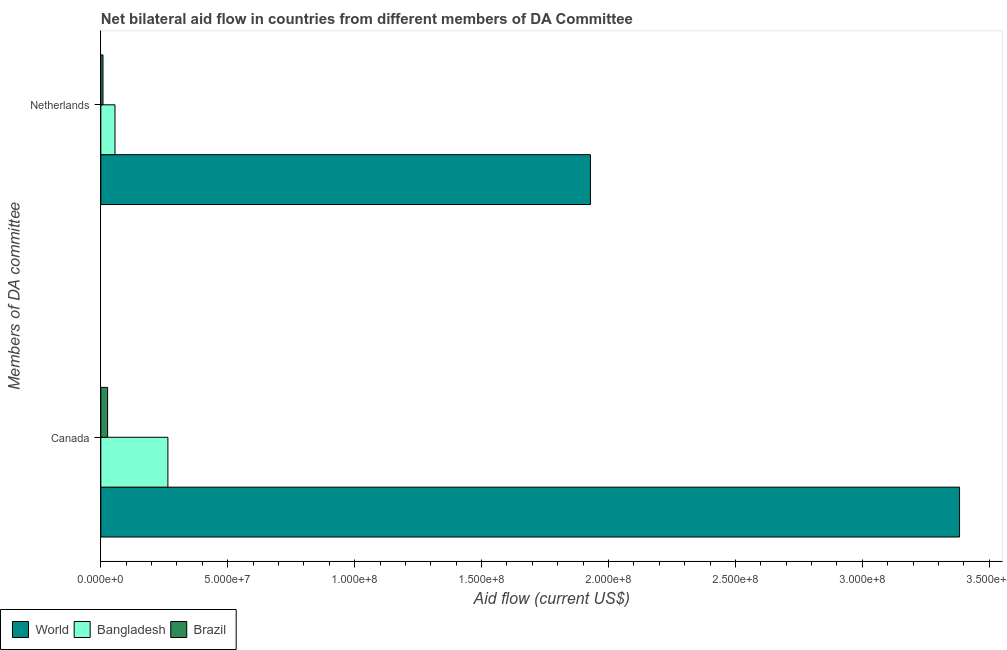How many different coloured bars are there?
Keep it short and to the point. 3. Are the number of bars on each tick of the Y-axis equal?
Your answer should be very brief. Yes. How many bars are there on the 1st tick from the top?
Provide a short and direct response. 3. How many bars are there on the 1st tick from the bottom?
Your answer should be compact. 3. What is the amount of aid given by canada in World?
Your answer should be compact. 3.38e+08. Across all countries, what is the maximum amount of aid given by canada?
Give a very brief answer. 3.38e+08. Across all countries, what is the minimum amount of aid given by netherlands?
Make the answer very short. 8.50e+05. What is the total amount of aid given by canada in the graph?
Your answer should be very brief. 3.67e+08. What is the difference between the amount of aid given by netherlands in World and that in Brazil?
Offer a terse response. 1.92e+08. What is the difference between the amount of aid given by canada in World and the amount of aid given by netherlands in Bangladesh?
Provide a short and direct response. 3.33e+08. What is the average amount of aid given by canada per country?
Ensure brevity in your answer.  1.22e+08. What is the difference between the amount of aid given by canada and amount of aid given by netherlands in Bangladesh?
Provide a short and direct response. 2.08e+07. What is the ratio of the amount of aid given by canada in World to that in Bangladesh?
Ensure brevity in your answer.  12.81. Is the amount of aid given by canada in World less than that in Brazil?
Your response must be concise. No. How many bars are there?
Make the answer very short. 6. Are the values on the major ticks of X-axis written in scientific E-notation?
Give a very brief answer. Yes. Does the graph contain any zero values?
Make the answer very short. No. Does the graph contain grids?
Give a very brief answer. No. Where does the legend appear in the graph?
Provide a succinct answer. Bottom left. How are the legend labels stacked?
Provide a short and direct response. Horizontal. What is the title of the graph?
Offer a very short reply. Net bilateral aid flow in countries from different members of DA Committee. Does "United Arab Emirates" appear as one of the legend labels in the graph?
Ensure brevity in your answer.  No. What is the label or title of the Y-axis?
Your answer should be compact. Members of DA committee. What is the Aid flow (current US$) of World in Canada?
Make the answer very short. 3.38e+08. What is the Aid flow (current US$) of Bangladesh in Canada?
Ensure brevity in your answer.  2.64e+07. What is the Aid flow (current US$) in Brazil in Canada?
Make the answer very short. 2.67e+06. What is the Aid flow (current US$) of World in Netherlands?
Provide a short and direct response. 1.93e+08. What is the Aid flow (current US$) of Bangladesh in Netherlands?
Ensure brevity in your answer.  5.58e+06. What is the Aid flow (current US$) of Brazil in Netherlands?
Your response must be concise. 8.50e+05. Across all Members of DA committee, what is the maximum Aid flow (current US$) in World?
Your answer should be compact. 3.38e+08. Across all Members of DA committee, what is the maximum Aid flow (current US$) of Bangladesh?
Give a very brief answer. 2.64e+07. Across all Members of DA committee, what is the maximum Aid flow (current US$) of Brazil?
Your answer should be very brief. 2.67e+06. Across all Members of DA committee, what is the minimum Aid flow (current US$) of World?
Your response must be concise. 1.93e+08. Across all Members of DA committee, what is the minimum Aid flow (current US$) in Bangladesh?
Your response must be concise. 5.58e+06. Across all Members of DA committee, what is the minimum Aid flow (current US$) of Brazil?
Offer a terse response. 8.50e+05. What is the total Aid flow (current US$) in World in the graph?
Your response must be concise. 5.31e+08. What is the total Aid flow (current US$) in Bangladesh in the graph?
Your response must be concise. 3.20e+07. What is the total Aid flow (current US$) in Brazil in the graph?
Your response must be concise. 3.52e+06. What is the difference between the Aid flow (current US$) of World in Canada and that in Netherlands?
Offer a terse response. 1.45e+08. What is the difference between the Aid flow (current US$) of Bangladesh in Canada and that in Netherlands?
Your answer should be very brief. 2.08e+07. What is the difference between the Aid flow (current US$) of Brazil in Canada and that in Netherlands?
Your answer should be very brief. 1.82e+06. What is the difference between the Aid flow (current US$) in World in Canada and the Aid flow (current US$) in Bangladesh in Netherlands?
Your answer should be compact. 3.33e+08. What is the difference between the Aid flow (current US$) of World in Canada and the Aid flow (current US$) of Brazil in Netherlands?
Offer a terse response. 3.37e+08. What is the difference between the Aid flow (current US$) in Bangladesh in Canada and the Aid flow (current US$) in Brazil in Netherlands?
Offer a very short reply. 2.56e+07. What is the average Aid flow (current US$) of World per Members of DA committee?
Your answer should be compact. 2.66e+08. What is the average Aid flow (current US$) in Bangladesh per Members of DA committee?
Keep it short and to the point. 1.60e+07. What is the average Aid flow (current US$) in Brazil per Members of DA committee?
Offer a very short reply. 1.76e+06. What is the difference between the Aid flow (current US$) in World and Aid flow (current US$) in Bangladesh in Canada?
Offer a terse response. 3.12e+08. What is the difference between the Aid flow (current US$) in World and Aid flow (current US$) in Brazil in Canada?
Provide a succinct answer. 3.36e+08. What is the difference between the Aid flow (current US$) in Bangladesh and Aid flow (current US$) in Brazil in Canada?
Your response must be concise. 2.38e+07. What is the difference between the Aid flow (current US$) in World and Aid flow (current US$) in Bangladesh in Netherlands?
Ensure brevity in your answer.  1.87e+08. What is the difference between the Aid flow (current US$) in World and Aid flow (current US$) in Brazil in Netherlands?
Offer a terse response. 1.92e+08. What is the difference between the Aid flow (current US$) in Bangladesh and Aid flow (current US$) in Brazil in Netherlands?
Offer a very short reply. 4.73e+06. What is the ratio of the Aid flow (current US$) in World in Canada to that in Netherlands?
Offer a terse response. 1.75. What is the ratio of the Aid flow (current US$) of Bangladesh in Canada to that in Netherlands?
Give a very brief answer. 4.73. What is the ratio of the Aid flow (current US$) in Brazil in Canada to that in Netherlands?
Offer a terse response. 3.14. What is the difference between the highest and the second highest Aid flow (current US$) in World?
Ensure brevity in your answer.  1.45e+08. What is the difference between the highest and the second highest Aid flow (current US$) in Bangladesh?
Your answer should be very brief. 2.08e+07. What is the difference between the highest and the second highest Aid flow (current US$) in Brazil?
Provide a succinct answer. 1.82e+06. What is the difference between the highest and the lowest Aid flow (current US$) in World?
Your answer should be compact. 1.45e+08. What is the difference between the highest and the lowest Aid flow (current US$) of Bangladesh?
Ensure brevity in your answer.  2.08e+07. What is the difference between the highest and the lowest Aid flow (current US$) in Brazil?
Ensure brevity in your answer.  1.82e+06. 